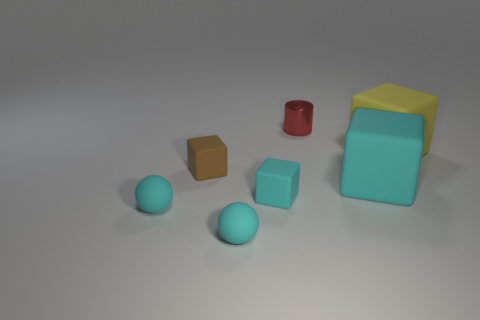Is there any other thing that is made of the same material as the large yellow thing?
Make the answer very short. Yes. Are the cyan block that is on the left side of the small shiny object and the small red cylinder made of the same material?
Offer a very short reply. No. Are there fewer blocks that are right of the cylinder than tiny rubber cubes?
Give a very brief answer. No. How many metallic objects are red cylinders or cyan balls?
Your response must be concise. 1. Is there anything else that is the same color as the small metal thing?
Offer a very short reply. No. There is a cyan rubber thing to the right of the small shiny thing; is it the same shape as the thing that is behind the large yellow matte object?
Make the answer very short. No. How many things are either gray rubber cylinders or cyan matte cubes to the left of the small metal object?
Make the answer very short. 1. What number of other objects are the same size as the red cylinder?
Provide a succinct answer. 4. Is the material of the cyan object that is on the right side of the red thing the same as the cyan block left of the small red metallic cylinder?
Provide a succinct answer. Yes. There is a red metallic object; how many large yellow rubber objects are in front of it?
Provide a short and direct response. 1. 